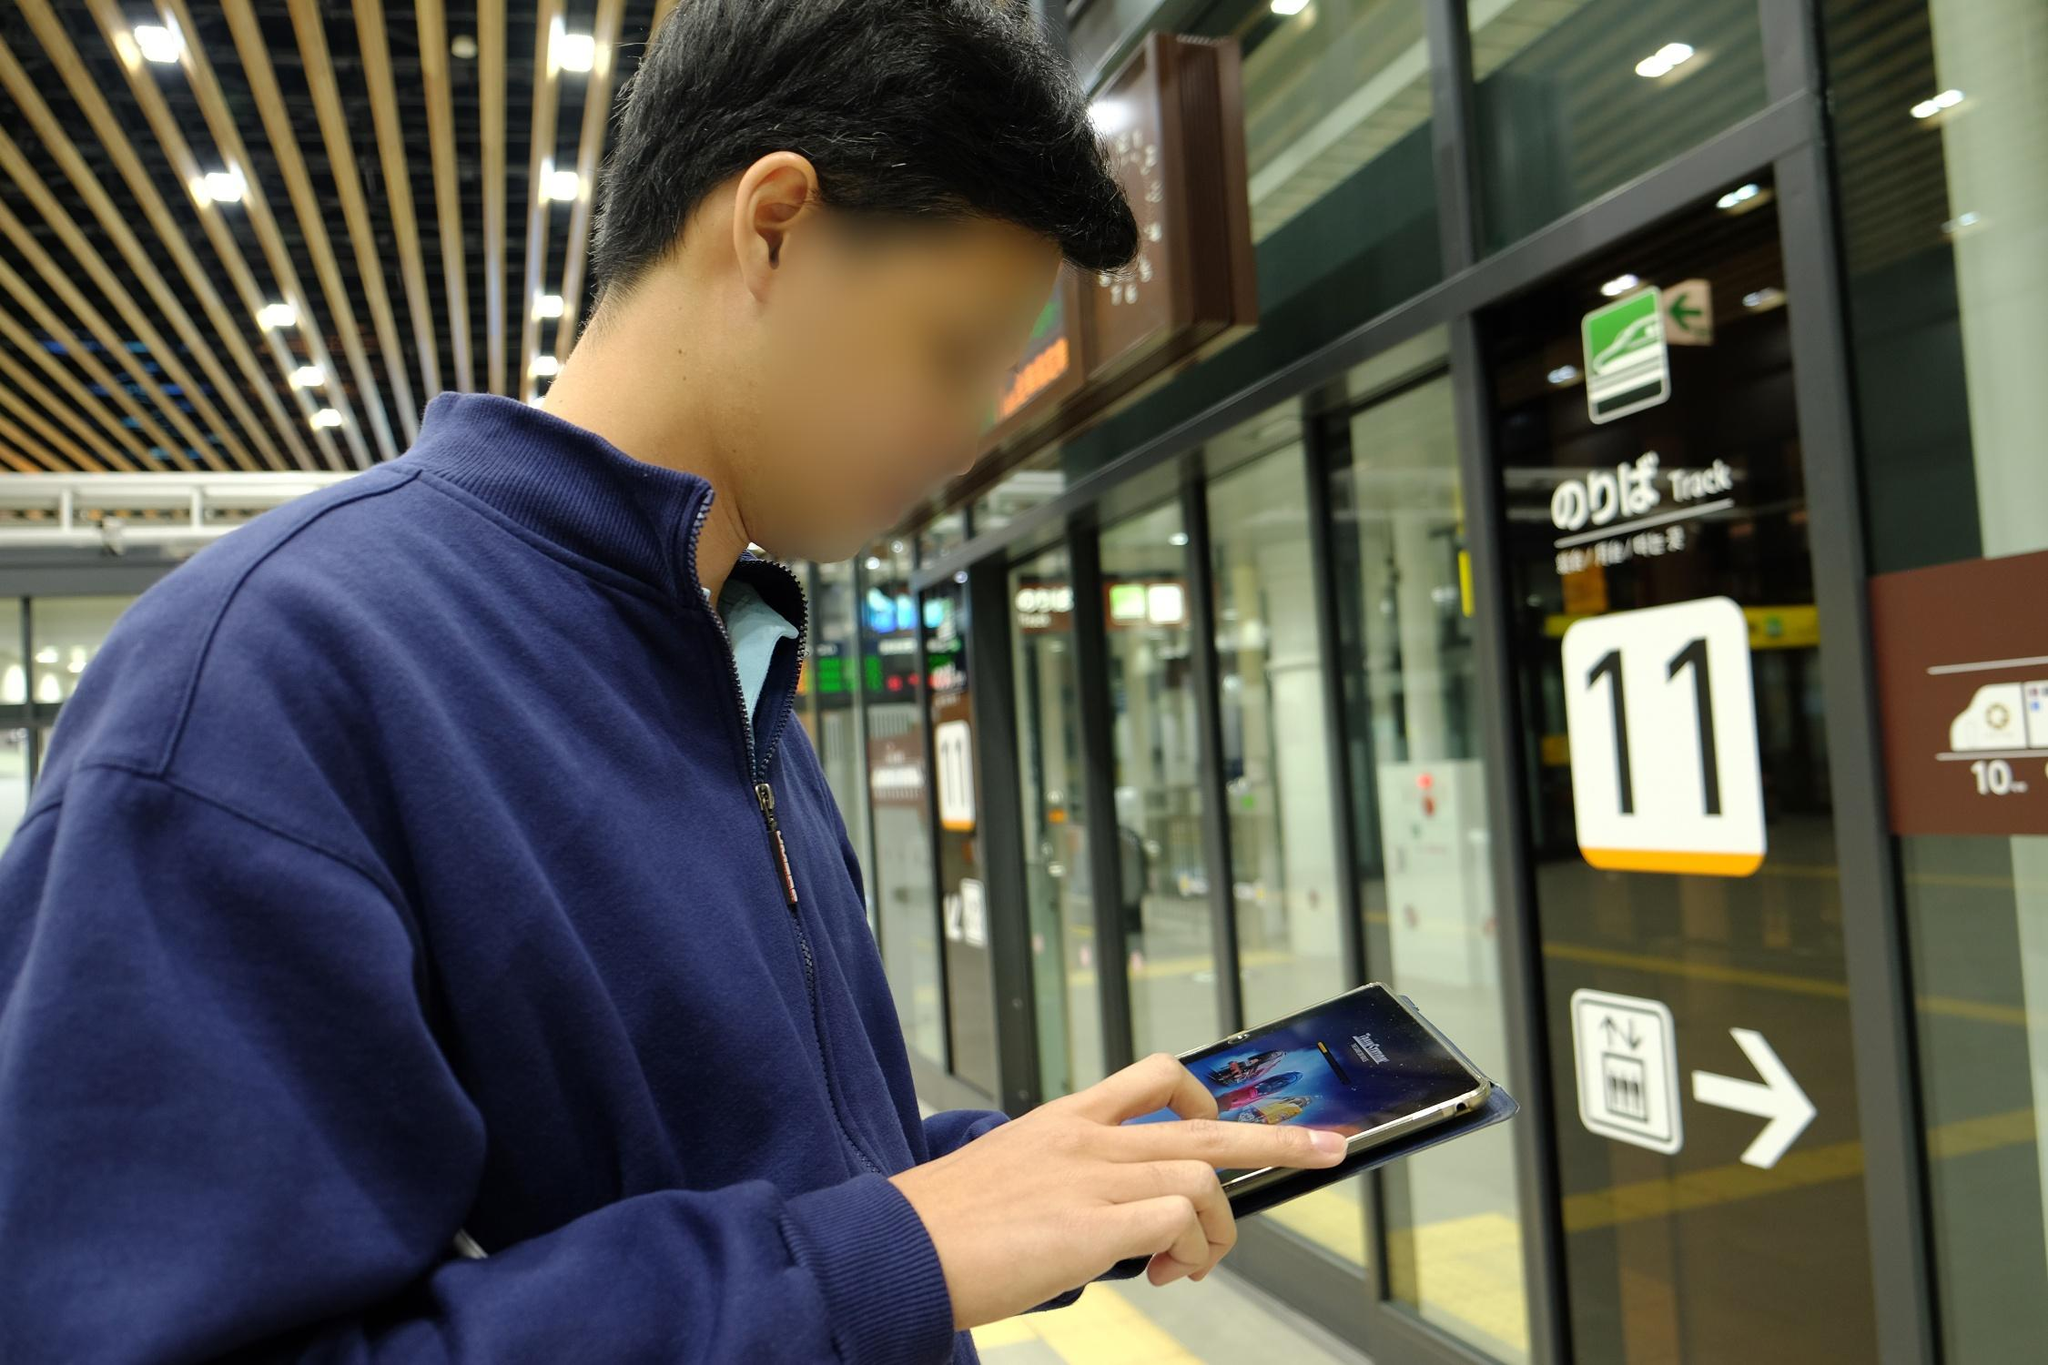Imagine you are in this train station; describe what you might hear, smell, and feel. Standing in this train station, you would likely hear a mix of bustling noises: the hum of conversations, the distant rumble of trains approaching or departing, and periodic announcements over the PA system. The scent of fresh coffee might waft through the air from a nearby café, mingling with the faint metallic smell typical of train stations. You might feel a light breeze as trains zip by, while also experiencing the slight chill of the air-conditioned station. The atmosphere is a dynamic blend of movement and anticipation, with a sense of purpose from people heading to their destinations. 